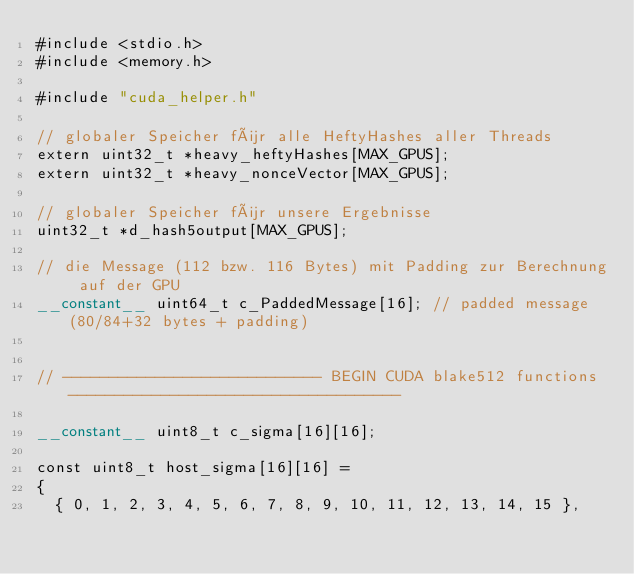Convert code to text. <code><loc_0><loc_0><loc_500><loc_500><_Cuda_>#include <stdio.h>
#include <memory.h>

#include "cuda_helper.h"

// globaler Speicher für alle HeftyHashes aller Threads
extern uint32_t *heavy_heftyHashes[MAX_GPUS];
extern uint32_t *heavy_nonceVector[MAX_GPUS];

// globaler Speicher für unsere Ergebnisse
uint32_t *d_hash5output[MAX_GPUS];

// die Message (112 bzw. 116 Bytes) mit Padding zur Berechnung auf der GPU
__constant__ uint64_t c_PaddedMessage[16]; // padded message (80/84+32 bytes + padding)


// ---------------------------- BEGIN CUDA blake512 functions ------------------------------------

__constant__ uint8_t c_sigma[16][16];

const uint8_t host_sigma[16][16] =
{
  { 0, 1, 2, 3, 4, 5, 6, 7, 8, 9, 10, 11, 12, 13, 14, 15 },</code> 